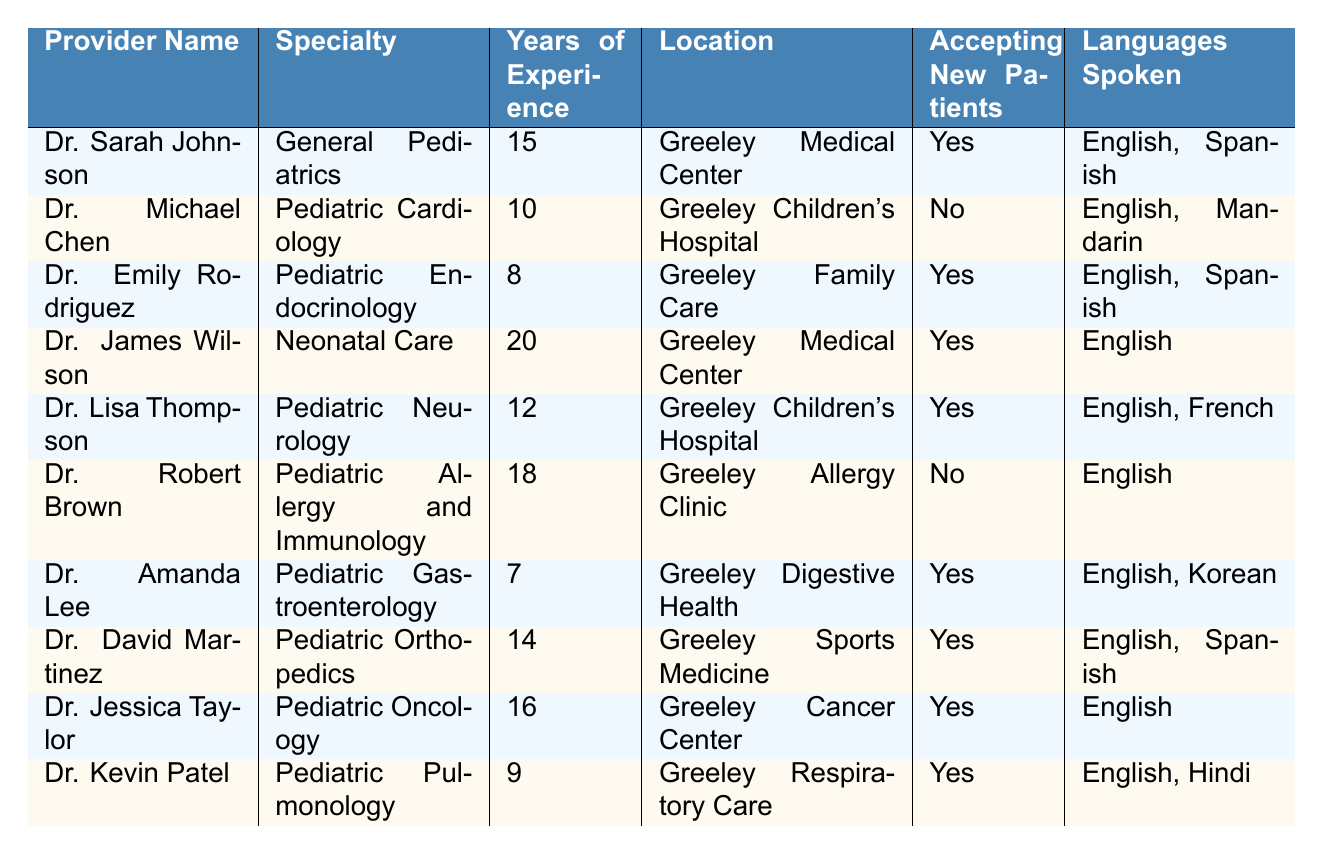What is the name of the provider who specializes in Pediatric Cardiology? Looking at the table, the second row lists Dr. Michael Chen under the specialty of Pediatric Cardiology.
Answer: Dr. Michael Chen How many years of experience does Dr. Emily Rodriguez have? The row for Dr. Emily Rodriguez shows that she has 8 years of experience in Pediatric Endocrinology.
Answer: 8 Which providers are accepting new patients? By scanning the "Accepting New Patients" column, the providers with "Yes" listed are Dr. Sarah Johnson, Dr. Emily Rodriguez, Dr. James Wilson, Dr. Lisa Thompson, Dr. Amanda Lee, Dr. David Martinez, Dr. Jessica Taylor, and Dr. Kevin Patel.
Answer: Dr. Sarah Johnson, Dr. Emily Rodriguez, Dr. James Wilson, Dr. Lisa Thompson, Dr. Amanda Lee, Dr. David Martinez, Dr. Jessica Taylor, Dr. Kevin Patel What is the average years of experience among the providers listed? To find the average, we sum the years of experience: 15 + 10 + 8 + 20 + 12 + 18 + 7 + 14 + 16 + 9 =  138. There are 10 providers, so the average is 138/10 = 13.8.
Answer: 13.8 Are there any providers who speak both English and Spanish? By reviewing the "Languages Spoken" column, we see that Dr. Sarah Johnson, Dr. Emily Rodriguez, and Dr. David Martinez speak both English and Spanish.
Answer: Yes Which provider has the most years of experience, and what is their specialty? The provider with the most years of experience is Dr. James Wilson, with 20 years in Neonatal Care.
Answer: Dr. James Wilson, Neonatal Care How many specialties are represented in the list of pediatric providers? The specialties for the providers listed are General Pediatrics, Pediatric Cardiology, Pediatric Endocrinology, Neonatal Care, Pediatric Neurology, Pediatric Allergy and Immunology, Pediatric Gastroenterology, Pediatric Orthopedics, Pediatric Oncology, and Pediatric Pulmonology. This totals to 10 unique specialties.
Answer: 10 Which providers specialize in Pediatric Neurology and are accepting new patients? The table indicates that Dr. Lisa Thompson specializes in Pediatric Neurology and is accepting new patients.
Answer: Dr. Lisa Thompson Is there a provider who speaks Mandarin? The "Languages Spoken" column shows that Dr. Michael Chen speaks Mandarin.
Answer: Yes What is the difference in years of experience between the most and least experienced providers? The most experienced provider is Dr. James Wilson with 20 years, and the least experienced is Dr. Amanda Lee with 7 years. The difference is 20 - 7 = 13 years.
Answer: 13 